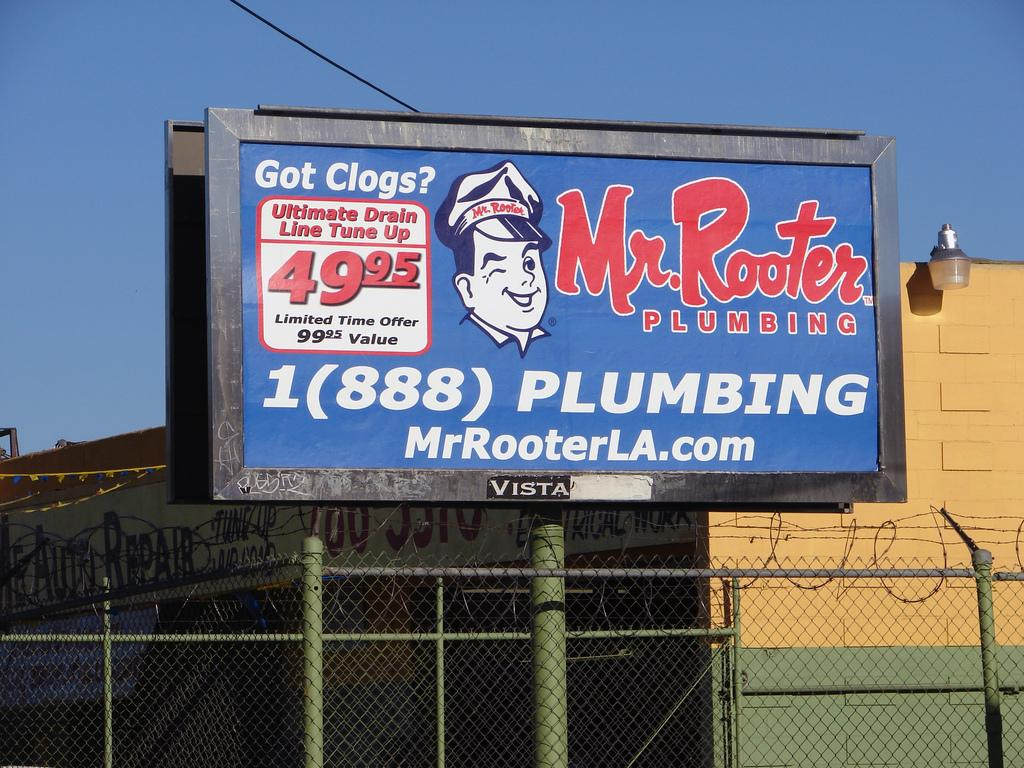What is located in the foreground of the image? There is a poster, net fencing, and poles in the foreground of the image. What type of establishment might the image depict? The image appears to depict a store. What can be seen in the background of the image? There is a lamp, a wire, and the sky visible in the background of the image. Is there any text visible in the image? Yes, there is text visible in the image. What type of meal is being prepared at the seashore in the image? There is no seashore or meal preparation present in the image. Can you describe the type of shake being offered at the store in the image? There is no mention of a shake or any food items in the image. 